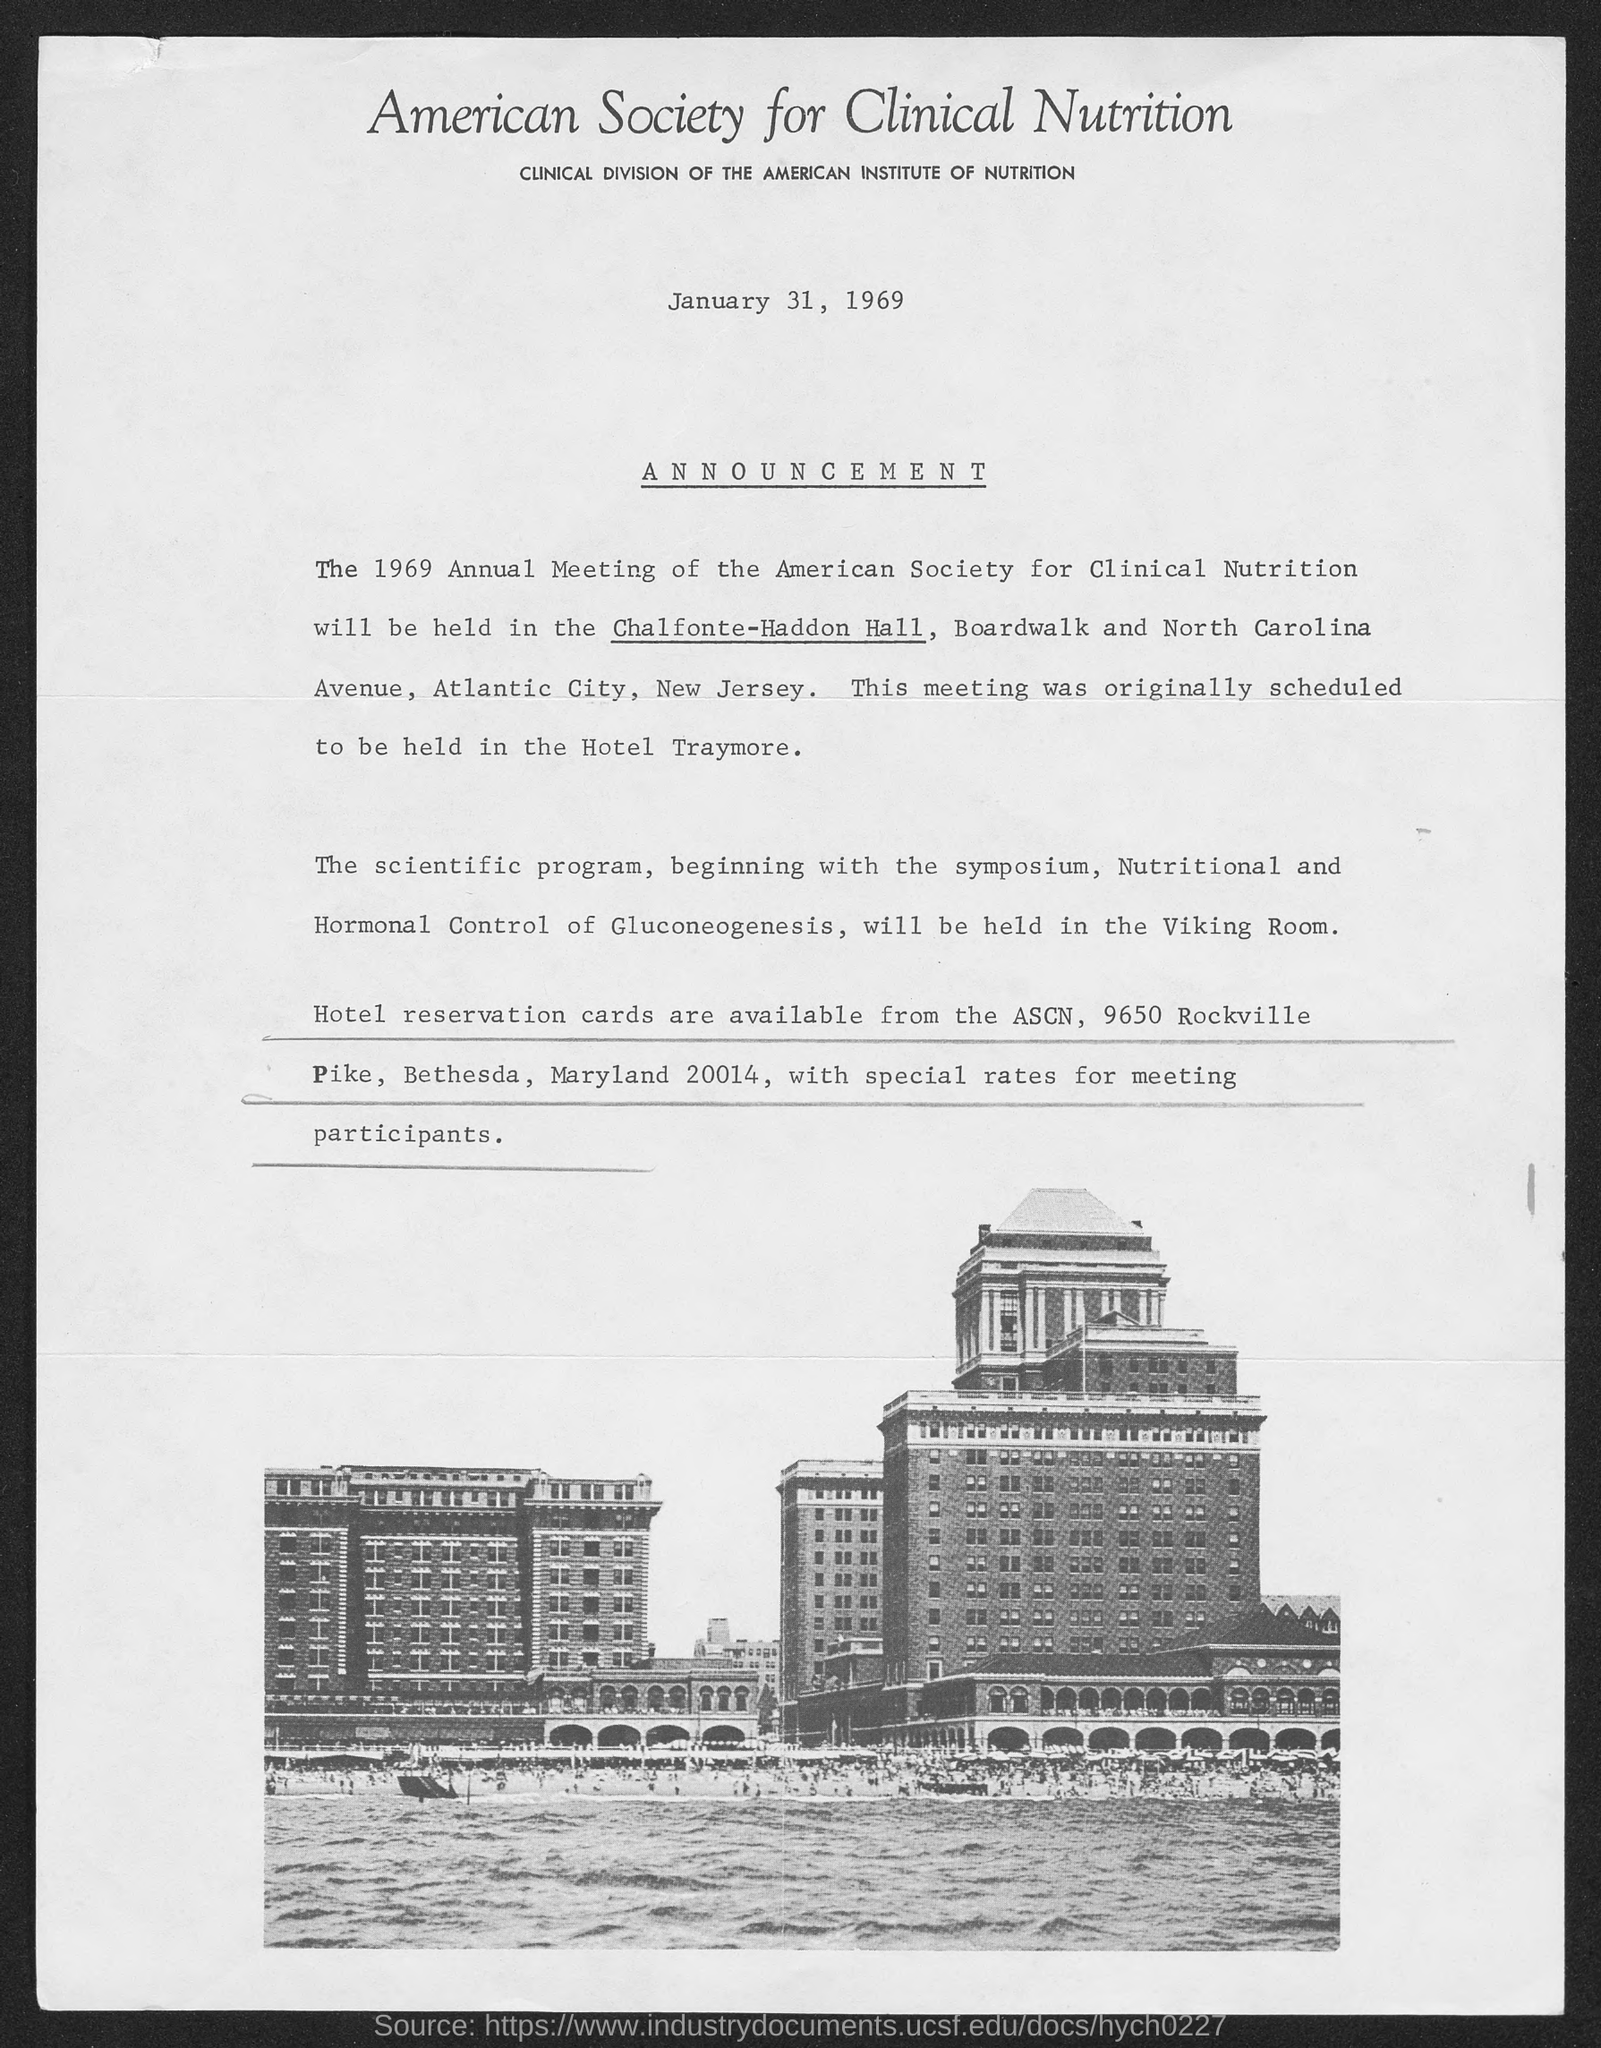Which association is the clinical division of the American Institute of Nutrition??
Your answer should be very brief. American Society for Clinical Nutrition. When is the document dated?
Offer a terse response. January 31, 1969. Where will the 1969 Annual Meeting be held?
Offer a terse response. Chalfonte-Haddon Hall, Boardwalk and North Carolina Avenue, Atlantic city, New Jersey. Where was the meeting originally scheduled to be held?
Provide a succinct answer. Hotel Traymore. Where will the scientific program be held?
Provide a succinct answer. The viking room. 